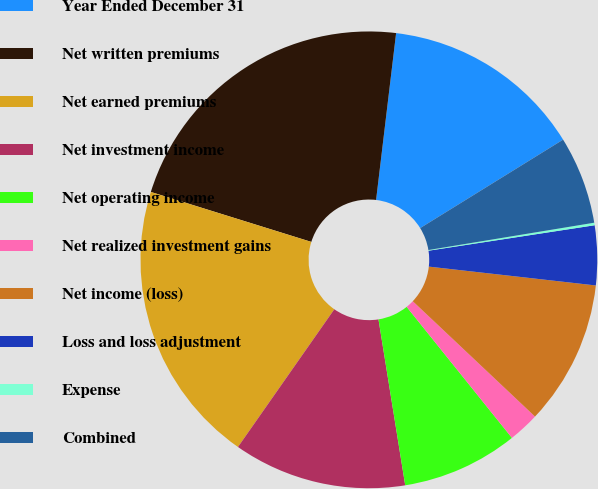Convert chart. <chart><loc_0><loc_0><loc_500><loc_500><pie_chart><fcel>Year Ended December 31<fcel>Net written premiums<fcel>Net earned premiums<fcel>Net investment income<fcel>Net operating income<fcel>Net realized investment gains<fcel>Net income (loss)<fcel>Loss and loss adjustment<fcel>Expense<fcel>Combined<nl><fcel>14.28%<fcel>22.1%<fcel>20.09%<fcel>12.26%<fcel>8.23%<fcel>2.19%<fcel>10.25%<fcel>4.21%<fcel>0.18%<fcel>6.22%<nl></chart> 